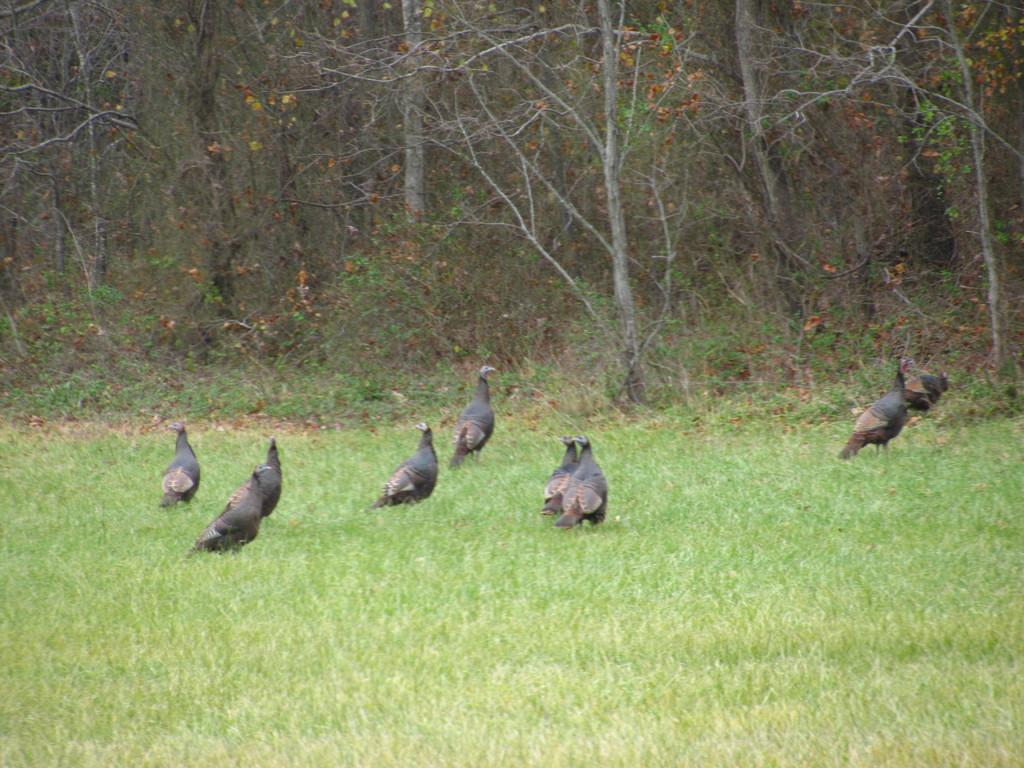What animals are present in the image? There are birds standing on the ground in the image. What can be seen in the distance behind the birds? There are trees, plants, and grass visible in the background of the image. What type of pin can be seen holding the birds together in the image? There is no pin present in the image, and the birds are not held together. 